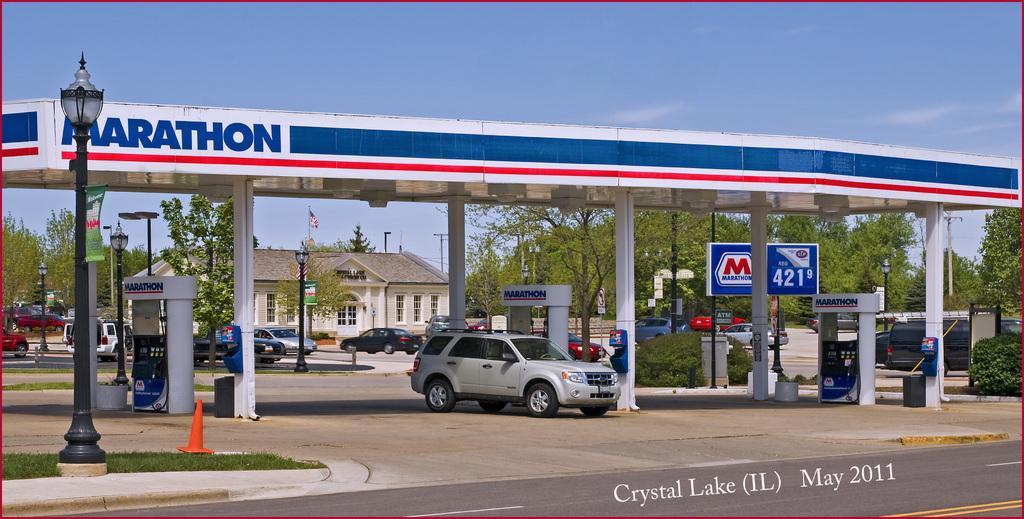Could you give a brief overview of what you see in this image? In this image, we can see a gas station and a few vehicles. We can also see a house and some trees and poles, boards. We can also see the ground and some grass. We can also see the sky. 